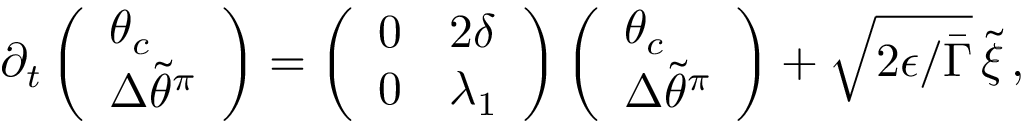<formula> <loc_0><loc_0><loc_500><loc_500>\begin{array} { r } { \partial _ { t } \left ( \begin{array} { l } { \theta _ { c } } \\ { { \Delta \widetilde { \theta } ^ { \pi } } } \end{array} \right ) = \left ( \begin{array} { l l } { 0 } & { 2 \delta } \\ { 0 } & { \lambda _ { 1 } } \end{array} \right ) \left ( \begin{array} { l } { \theta _ { c } } \\ { { \Delta \widetilde { \theta } ^ { \pi } } } \end{array} \right ) + \sqrt { 2 \epsilon / \bar { \Gamma } } \, \tilde { \xi } \, , } \end{array}</formula> 